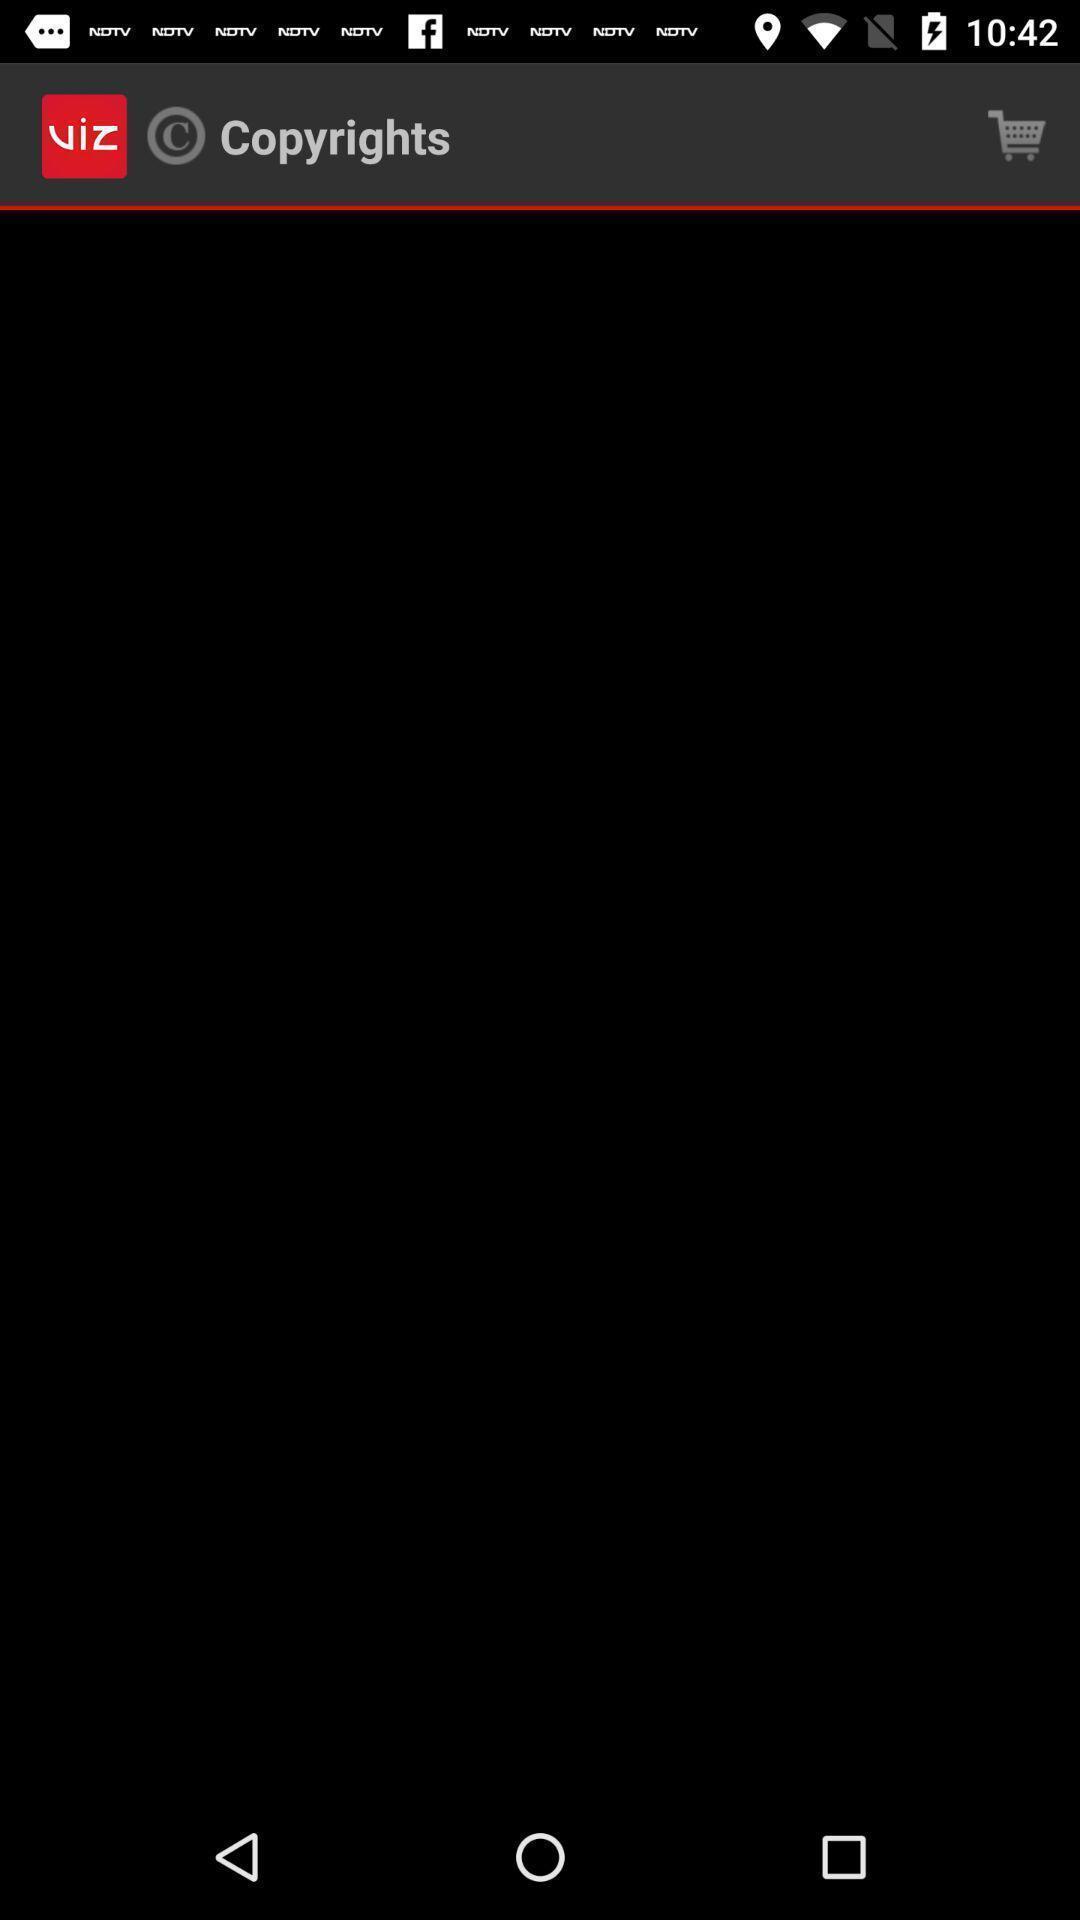Describe the key features of this screenshot. Screen showing copyrights option in shopping app. 